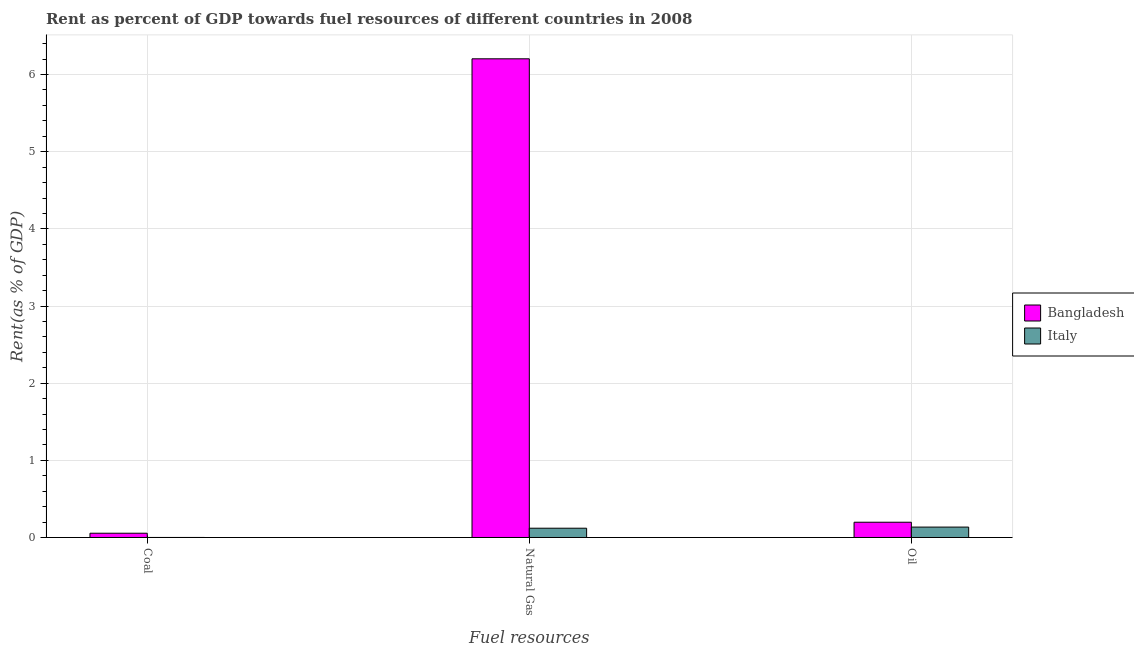Are the number of bars on each tick of the X-axis equal?
Provide a short and direct response. Yes. How many bars are there on the 3rd tick from the left?
Keep it short and to the point. 2. How many bars are there on the 2nd tick from the right?
Ensure brevity in your answer.  2. What is the label of the 1st group of bars from the left?
Your answer should be compact. Coal. What is the rent towards coal in Italy?
Your response must be concise. 0. Across all countries, what is the maximum rent towards coal?
Your answer should be very brief. 0.06. Across all countries, what is the minimum rent towards natural gas?
Offer a very short reply. 0.12. What is the total rent towards oil in the graph?
Make the answer very short. 0.33. What is the difference between the rent towards coal in Bangladesh and that in Italy?
Offer a terse response. 0.05. What is the difference between the rent towards coal in Bangladesh and the rent towards natural gas in Italy?
Give a very brief answer. -0.07. What is the average rent towards coal per country?
Your answer should be very brief. 0.03. What is the difference between the rent towards natural gas and rent towards coal in Bangladesh?
Offer a very short reply. 6.15. In how many countries, is the rent towards oil greater than 5.8 %?
Your response must be concise. 0. What is the ratio of the rent towards coal in Italy to that in Bangladesh?
Provide a succinct answer. 0.01. Is the rent towards natural gas in Italy less than that in Bangladesh?
Offer a very short reply. Yes. Is the difference between the rent towards coal in Bangladesh and Italy greater than the difference between the rent towards natural gas in Bangladesh and Italy?
Your response must be concise. No. What is the difference between the highest and the second highest rent towards coal?
Give a very brief answer. 0.05. What is the difference between the highest and the lowest rent towards coal?
Provide a succinct answer. 0.05. Is the sum of the rent towards coal in Italy and Bangladesh greater than the maximum rent towards natural gas across all countries?
Your answer should be very brief. No. What does the 2nd bar from the left in Natural Gas represents?
Ensure brevity in your answer.  Italy. Is it the case that in every country, the sum of the rent towards coal and rent towards natural gas is greater than the rent towards oil?
Your answer should be compact. No. What is the difference between two consecutive major ticks on the Y-axis?
Ensure brevity in your answer.  1. Are the values on the major ticks of Y-axis written in scientific E-notation?
Provide a short and direct response. No. Does the graph contain any zero values?
Offer a very short reply. No. How many legend labels are there?
Keep it short and to the point. 2. What is the title of the graph?
Your answer should be compact. Rent as percent of GDP towards fuel resources of different countries in 2008. Does "Iceland" appear as one of the legend labels in the graph?
Your response must be concise. No. What is the label or title of the X-axis?
Offer a terse response. Fuel resources. What is the label or title of the Y-axis?
Provide a short and direct response. Rent(as % of GDP). What is the Rent(as % of GDP) in Bangladesh in Coal?
Your answer should be compact. 0.06. What is the Rent(as % of GDP) in Italy in Coal?
Keep it short and to the point. 0. What is the Rent(as % of GDP) in Bangladesh in Natural Gas?
Provide a succinct answer. 6.2. What is the Rent(as % of GDP) in Italy in Natural Gas?
Offer a very short reply. 0.12. What is the Rent(as % of GDP) of Bangladesh in Oil?
Keep it short and to the point. 0.2. What is the Rent(as % of GDP) of Italy in Oil?
Provide a succinct answer. 0.13. Across all Fuel resources, what is the maximum Rent(as % of GDP) of Bangladesh?
Your answer should be compact. 6.2. Across all Fuel resources, what is the maximum Rent(as % of GDP) in Italy?
Your response must be concise. 0.13. Across all Fuel resources, what is the minimum Rent(as % of GDP) in Bangladesh?
Ensure brevity in your answer.  0.06. Across all Fuel resources, what is the minimum Rent(as % of GDP) in Italy?
Provide a succinct answer. 0. What is the total Rent(as % of GDP) in Bangladesh in the graph?
Give a very brief answer. 6.46. What is the total Rent(as % of GDP) of Italy in the graph?
Keep it short and to the point. 0.26. What is the difference between the Rent(as % of GDP) of Bangladesh in Coal and that in Natural Gas?
Your answer should be very brief. -6.15. What is the difference between the Rent(as % of GDP) in Italy in Coal and that in Natural Gas?
Provide a succinct answer. -0.12. What is the difference between the Rent(as % of GDP) in Bangladesh in Coal and that in Oil?
Provide a short and direct response. -0.14. What is the difference between the Rent(as % of GDP) in Italy in Coal and that in Oil?
Offer a very short reply. -0.13. What is the difference between the Rent(as % of GDP) in Bangladesh in Natural Gas and that in Oil?
Your response must be concise. 6.01. What is the difference between the Rent(as % of GDP) in Italy in Natural Gas and that in Oil?
Your response must be concise. -0.01. What is the difference between the Rent(as % of GDP) in Bangladesh in Coal and the Rent(as % of GDP) in Italy in Natural Gas?
Give a very brief answer. -0.07. What is the difference between the Rent(as % of GDP) in Bangladesh in Coal and the Rent(as % of GDP) in Italy in Oil?
Provide a succinct answer. -0.08. What is the difference between the Rent(as % of GDP) in Bangladesh in Natural Gas and the Rent(as % of GDP) in Italy in Oil?
Your answer should be very brief. 6.07. What is the average Rent(as % of GDP) in Bangladesh per Fuel resources?
Your answer should be very brief. 2.15. What is the average Rent(as % of GDP) in Italy per Fuel resources?
Ensure brevity in your answer.  0.09. What is the difference between the Rent(as % of GDP) of Bangladesh and Rent(as % of GDP) of Italy in Coal?
Provide a short and direct response. 0.05. What is the difference between the Rent(as % of GDP) of Bangladesh and Rent(as % of GDP) of Italy in Natural Gas?
Keep it short and to the point. 6.08. What is the difference between the Rent(as % of GDP) in Bangladesh and Rent(as % of GDP) in Italy in Oil?
Your answer should be compact. 0.06. What is the ratio of the Rent(as % of GDP) of Bangladesh in Coal to that in Natural Gas?
Your answer should be compact. 0.01. What is the ratio of the Rent(as % of GDP) of Italy in Coal to that in Natural Gas?
Ensure brevity in your answer.  0. What is the ratio of the Rent(as % of GDP) of Bangladesh in Coal to that in Oil?
Give a very brief answer. 0.28. What is the ratio of the Rent(as % of GDP) of Italy in Coal to that in Oil?
Make the answer very short. 0. What is the ratio of the Rent(as % of GDP) of Bangladesh in Natural Gas to that in Oil?
Give a very brief answer. 31.37. What is the ratio of the Rent(as % of GDP) in Italy in Natural Gas to that in Oil?
Provide a short and direct response. 0.89. What is the difference between the highest and the second highest Rent(as % of GDP) of Bangladesh?
Your response must be concise. 6.01. What is the difference between the highest and the second highest Rent(as % of GDP) in Italy?
Keep it short and to the point. 0.01. What is the difference between the highest and the lowest Rent(as % of GDP) of Bangladesh?
Your answer should be compact. 6.15. What is the difference between the highest and the lowest Rent(as % of GDP) of Italy?
Your response must be concise. 0.13. 